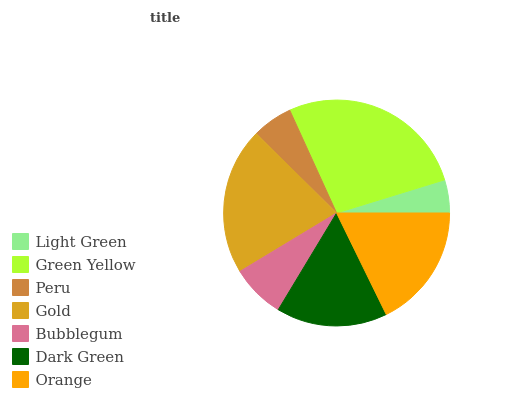Is Light Green the minimum?
Answer yes or no. Yes. Is Green Yellow the maximum?
Answer yes or no. Yes. Is Peru the minimum?
Answer yes or no. No. Is Peru the maximum?
Answer yes or no. No. Is Green Yellow greater than Peru?
Answer yes or no. Yes. Is Peru less than Green Yellow?
Answer yes or no. Yes. Is Peru greater than Green Yellow?
Answer yes or no. No. Is Green Yellow less than Peru?
Answer yes or no. No. Is Dark Green the high median?
Answer yes or no. Yes. Is Dark Green the low median?
Answer yes or no. Yes. Is Orange the high median?
Answer yes or no. No. Is Gold the low median?
Answer yes or no. No. 